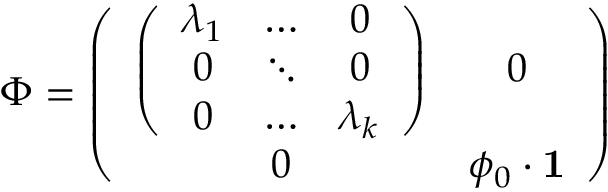Convert formula to latex. <formula><loc_0><loc_0><loc_500><loc_500>\Phi = \left ( \begin{array} { c c } { { \left ( \begin{array} { c c c } { { \lambda _ { 1 } } } & { \dots } & { 0 } \\ { 0 } & { \ddots } & { 0 } \\ { 0 } & { \dots } & { { \lambda _ { k } } } \end{array} \right ) } } & { 0 } \\ { 0 } & { { \phi _ { 0 } \cdot { 1 } } } \end{array} \right )</formula> 